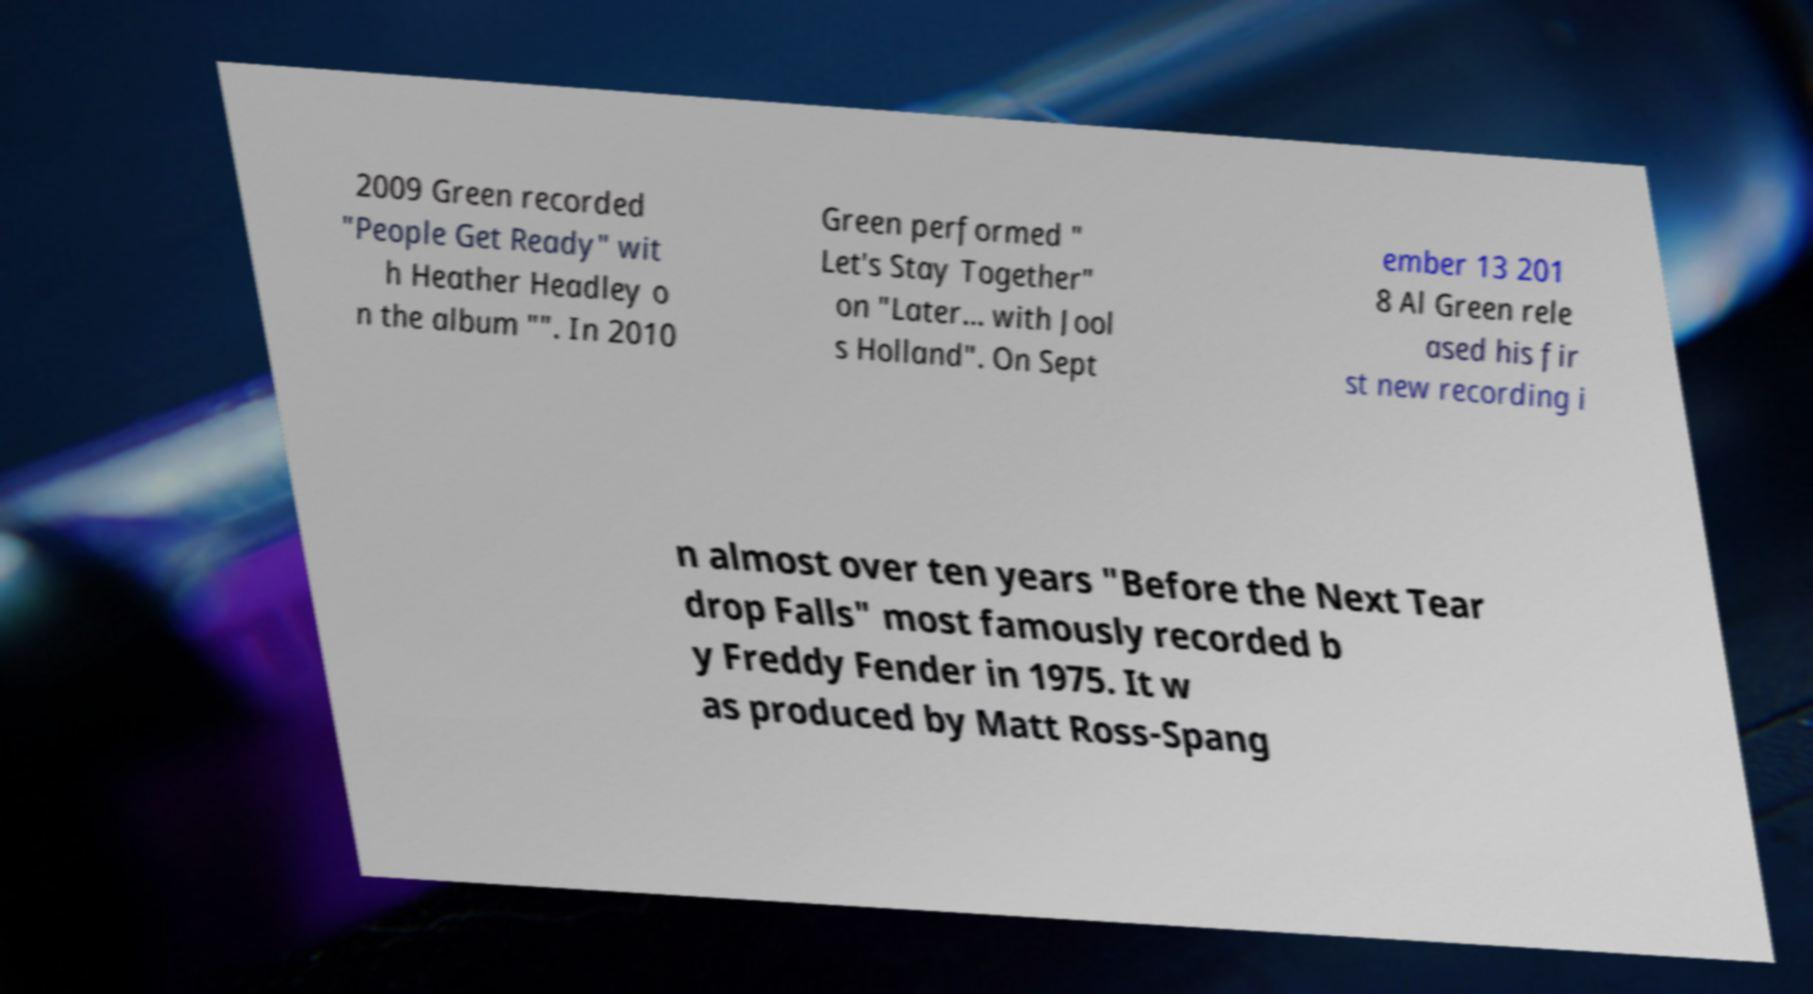For documentation purposes, I need the text within this image transcribed. Could you provide that? 2009 Green recorded "People Get Ready" wit h Heather Headley o n the album "". In 2010 Green performed " Let's Stay Together" on "Later... with Jool s Holland". On Sept ember 13 201 8 Al Green rele ased his fir st new recording i n almost over ten years "Before the Next Tear drop Falls" most famously recorded b y Freddy Fender in 1975. It w as produced by Matt Ross-Spang 